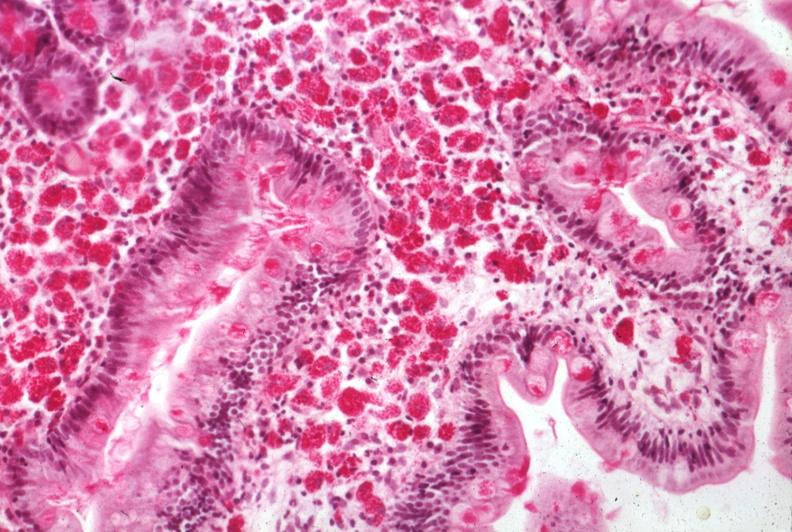s whipples disease present?
Answer the question using a single word or phrase. Yes 